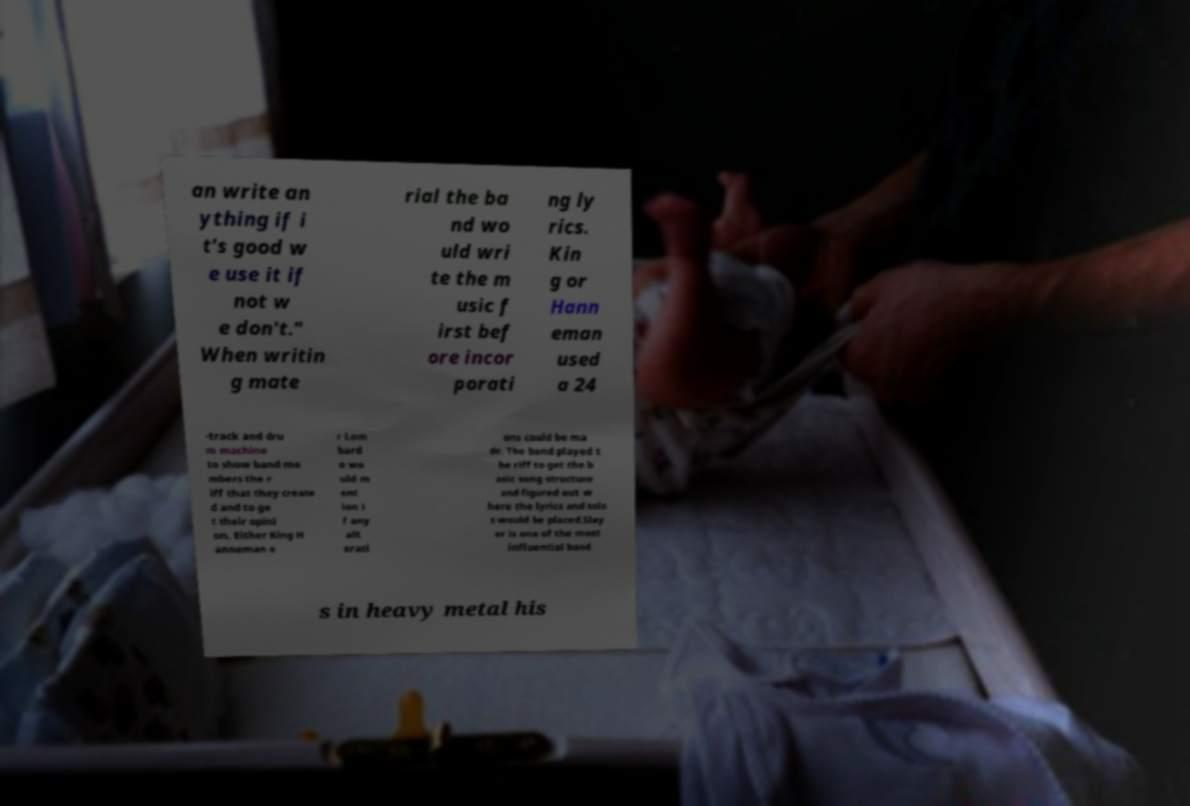There's text embedded in this image that I need extracted. Can you transcribe it verbatim? an write an ything if i t's good w e use it if not w e don't." When writin g mate rial the ba nd wo uld wri te the m usic f irst bef ore incor porati ng ly rics. Kin g or Hann eman used a 24 -track and dru m machine to show band me mbers the r iff that they create d and to ge t their opini on. Either King H anneman o r Lom bard o wo uld m ent ion i f any alt erati ons could be ma de. The band played t he riff to get the b asic song structure and figured out w here the lyrics and solo s would be placed.Slay er is one of the most influential band s in heavy metal his 